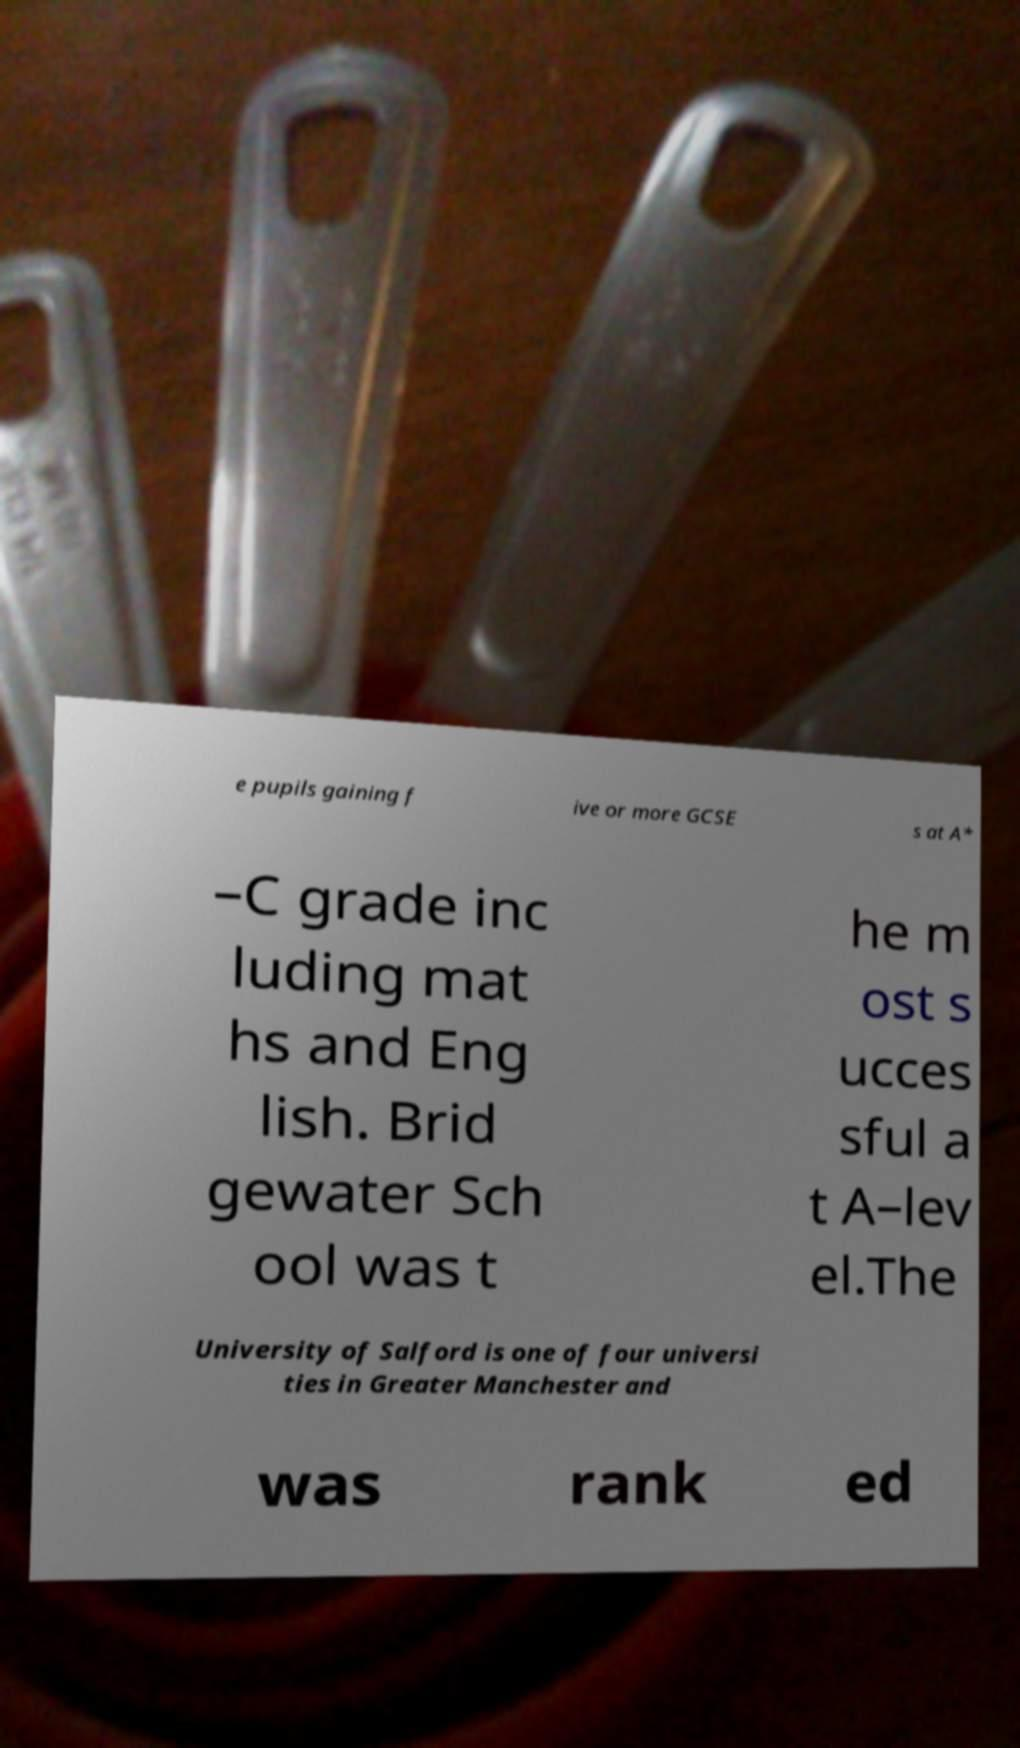Could you extract and type out the text from this image? e pupils gaining f ive or more GCSE s at A* –C grade inc luding mat hs and Eng lish. Brid gewater Sch ool was t he m ost s ucces sful a t A–lev el.The University of Salford is one of four universi ties in Greater Manchester and was rank ed 